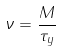Convert formula to latex. <formula><loc_0><loc_0><loc_500><loc_500>\nu = \frac { M } { \tau _ { y } }</formula> 